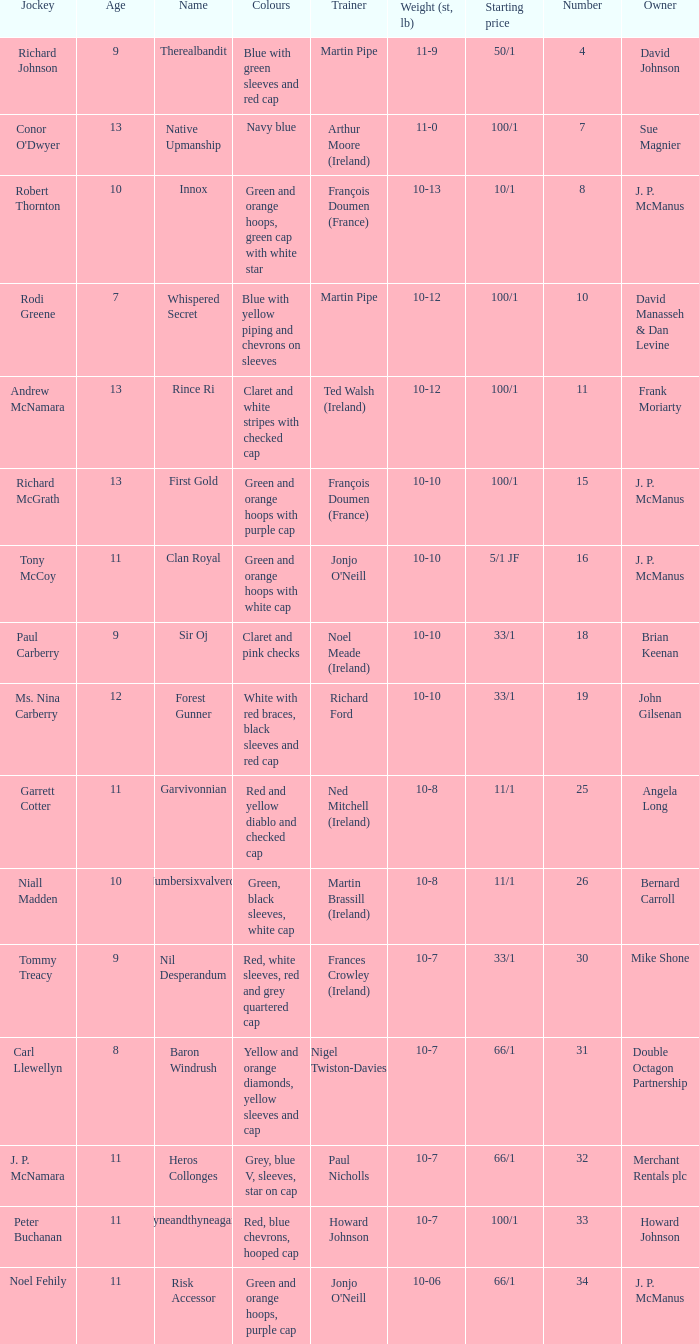How many age entries had a weight of 10-7 and an owner of Double Octagon Partnership? 1.0. 